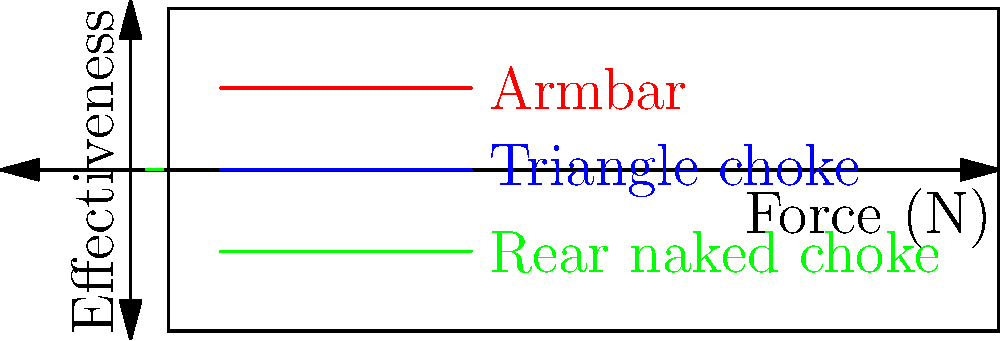Based on the force diagram comparing the effectiveness of different submission holds in Brazilian jiu-jitsu, which submission technique appears to be the most effective across all force levels? To determine the most effective submission technique across all force levels, we need to analyze the graph:

1. The graph shows three submission techniques: Armbar (red), Triangle choke (blue), and Rear naked choke (green).

2. The x-axis represents the applied force in Newtons (N), while the y-axis represents the effectiveness of the technique.

3. For each technique, we can observe how its effectiveness changes as the applied force increases:

   Armbar: 
   - At 100N: ~0.6 effectiveness
   - At 150N: ~0.8 effectiveness
   - At 200N: ~0.9 effectiveness

   Triangle choke:
   - At 100N: ~0.5 effectiveness
   - At 150N: ~0.7 effectiveness
   - At 200N: ~0.85 effectiveness

   Rear naked choke:
   - At 100N: ~0.4 effectiveness
   - At 150N: ~0.6 effectiveness
   - At 200N: ~0.75 effectiveness

4. Comparing the three techniques, we can see that the Armbar (red line) consistently shows the highest effectiveness at all force levels.

5. The Armbar line is above the other two lines throughout the entire graph, indicating superior effectiveness across all measured force levels.

Therefore, based on this force diagram, the Armbar appears to be the most effective submission technique across all force levels.
Answer: Armbar 